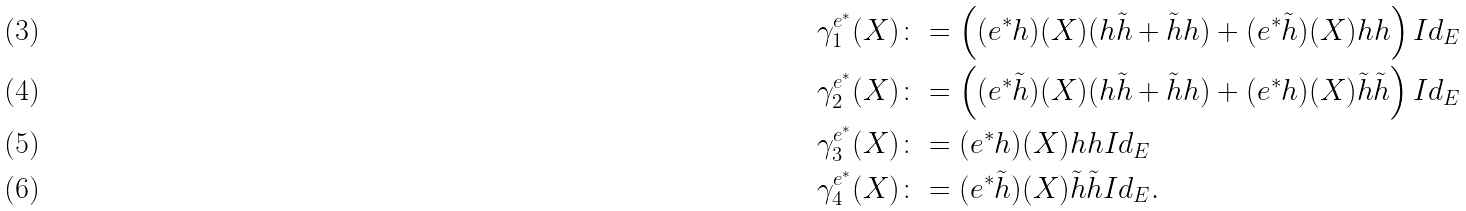<formula> <loc_0><loc_0><loc_500><loc_500>\gamma ^ { e ^ { * } } _ { 1 } ( X ) & \colon = \left ( ( e ^ { * } h ) ( X ) ( h \tilde { h } + \tilde { h } h ) + ( e ^ { * } \tilde { h } ) ( X ) h h \right ) I d _ { E } \\ \gamma ^ { e ^ { * } } _ { 2 } ( X ) & \colon = \left ( ( e ^ { * } \tilde { h } ) ( X ) ( h \tilde { h } + \tilde { h } h ) + ( e ^ { * } h ) ( X ) \tilde { h } \tilde { h } \right ) I d _ { E } \\ \gamma ^ { e ^ { * } } _ { 3 } ( X ) & \colon = ( e ^ { * } h ) ( X ) h h I d _ { E } \\ \gamma ^ { e ^ { * } } _ { 4 } ( X ) & \colon = ( e ^ { * } \tilde { h } ) ( X ) \tilde { h } \tilde { h } I d _ { E } .</formula> 